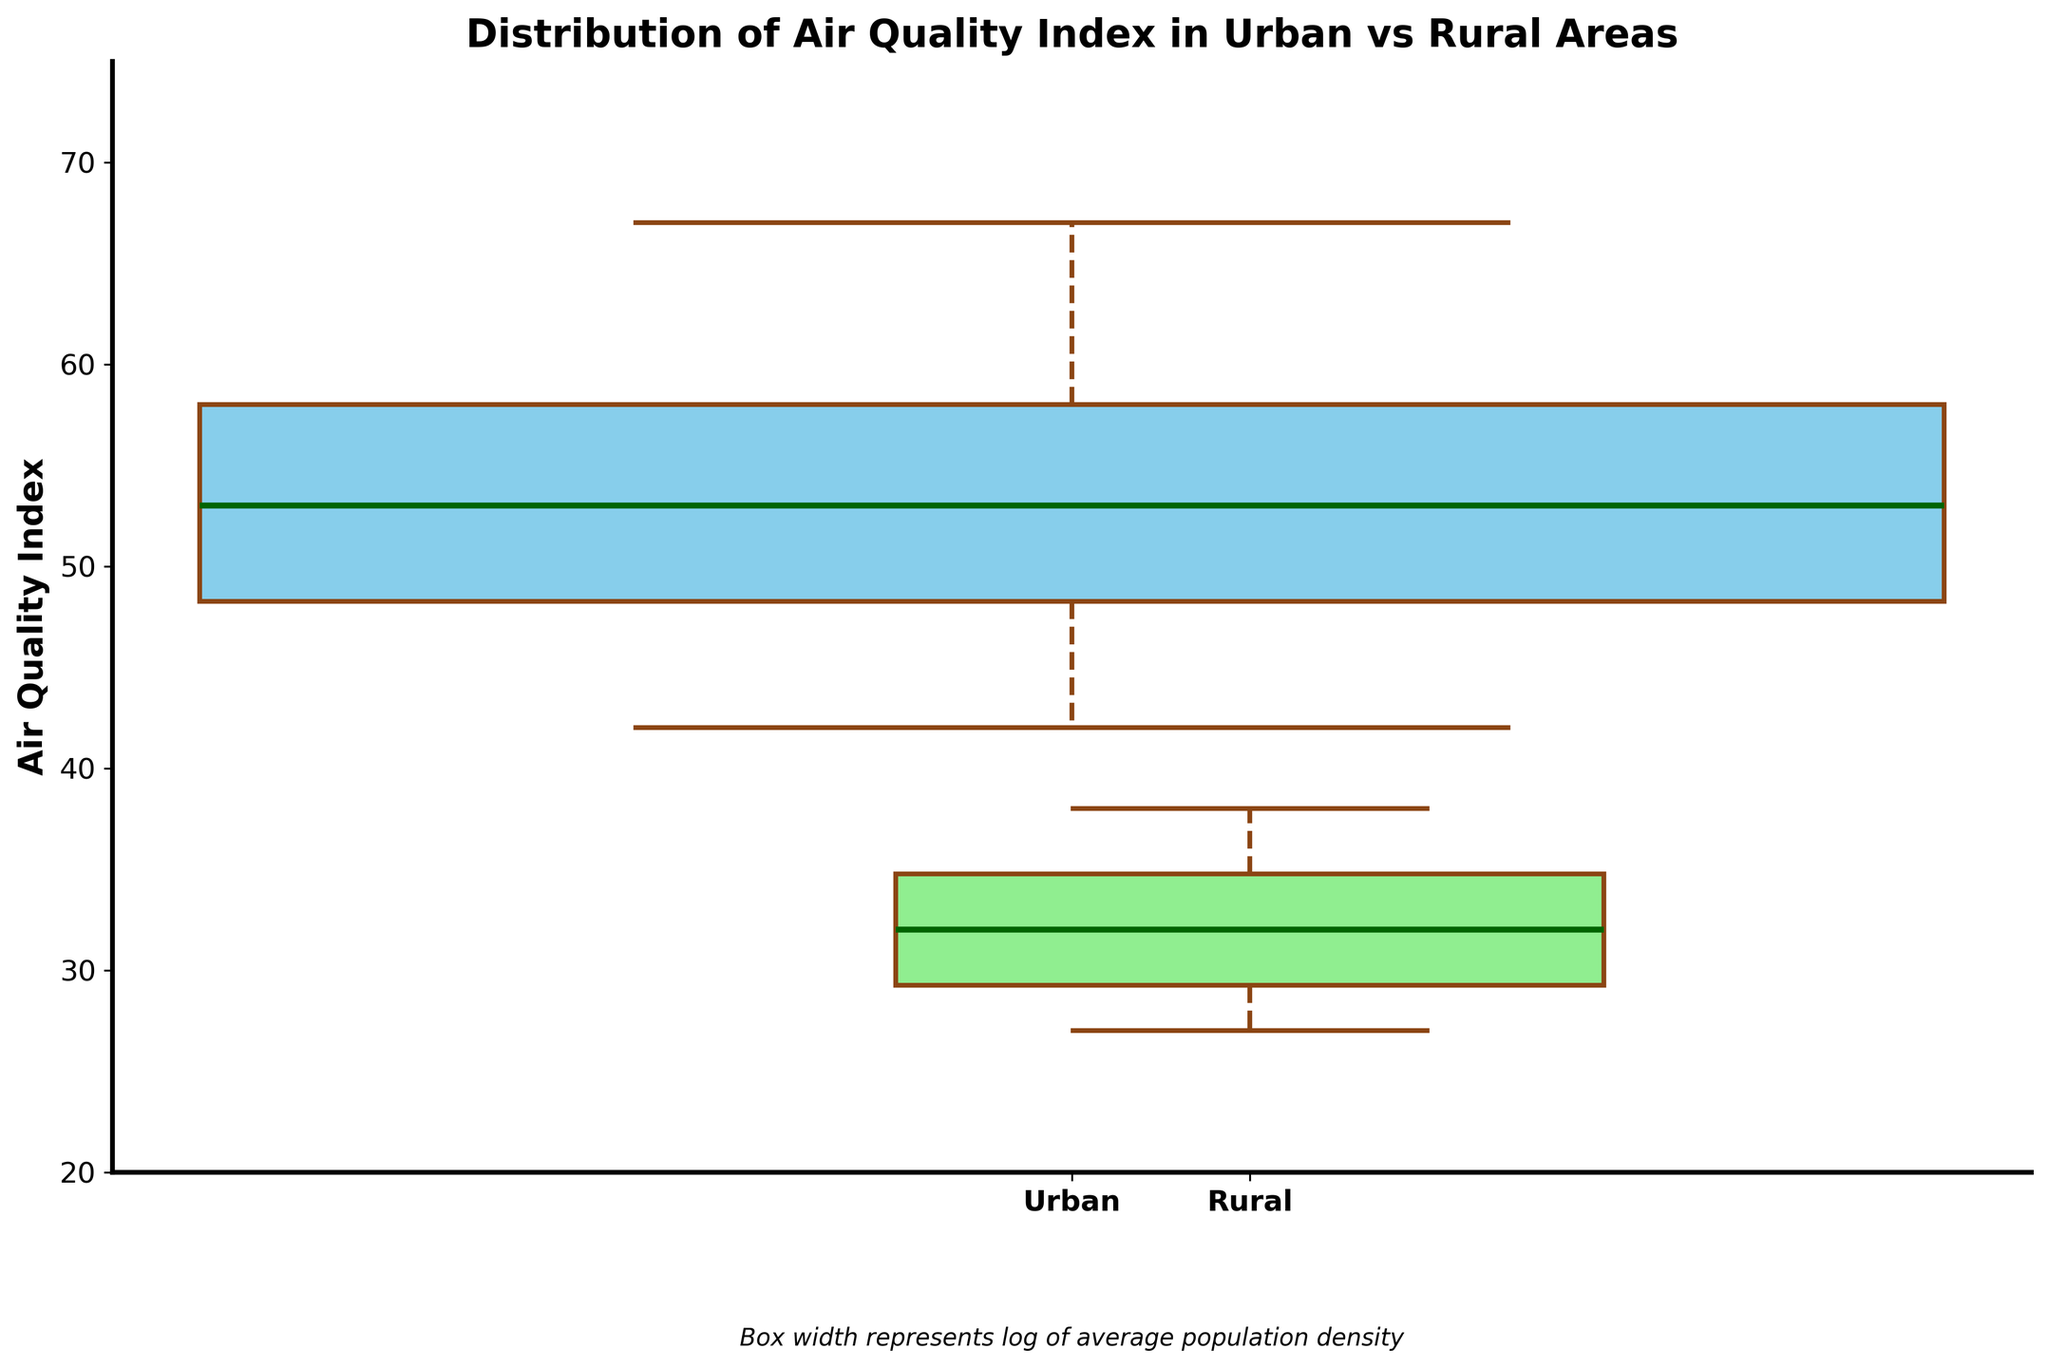What are the labels on the x-axis of the figure? The x-axis labels can be identified by looking at the bottom of the box plot. There will be descriptive labels indicating the two categories being compared.
Answer: Urban, Rural What is the title of the figure? The title of the figure is found at the top center and succinctly describes the nature and purpose of the plot.
Answer: Distribution of Air Quality Index in Urban vs Rural Areas What does the width of each box in the box plot represent? The width of each box in a variable width box plot signifies the log of the average population density for each category. This is specified by the description text under the x-axis.
Answer: Log of average population density Which location type has a higher median Air Quality Index? To find the median, examine the line inside each box plot. The taller line indicates a higher median value.
Answer: Urban Between Urban and Rural areas, which has more variability in the Air Quality Index? The variability in each category can be identified by the length of the box and whiskers. The longer the combined length of the box and whiskers, the more variability there is.
Answer: Urban Based on the box plot, what can you infer about the general air quality in Urban areas compared to Rural areas? Urban areas typically have a higher Air Quality Index as indicated by the position of the boxes higher up on the y-axis. The median is also higher for urban areas, reflecting worse air quality than rural areas.
Answer: Worse in urban areas What is the Air Quality Index range for rural areas in the plot? The range is determined by identifying the lowest and highest points of the whiskers for rural areas on the y-axis.
Answer: 27 to 38 What is one difference in visual presentation between the boxes for Urban and Rural areas? Noticeable differences in visual characteristics include the width and the colors of the boxes, which can be used to distinguish between the two categories.
Answer: Width and color Is the interquartile range (IQR) for urban areas larger or smaller compared to rural areas? The IQR is the distance between the first and third quartiles (the top and bottom of the box). Compare the two boxes to determine which has a larger IQR.
Answer: Larger for urban areas Which category has a smaller average population density, and how is this indicated in the plot? The smaller average population density is indicated by the narrower width of the box. Find which box plot is narrower to answer the question.
Answer: Rural 